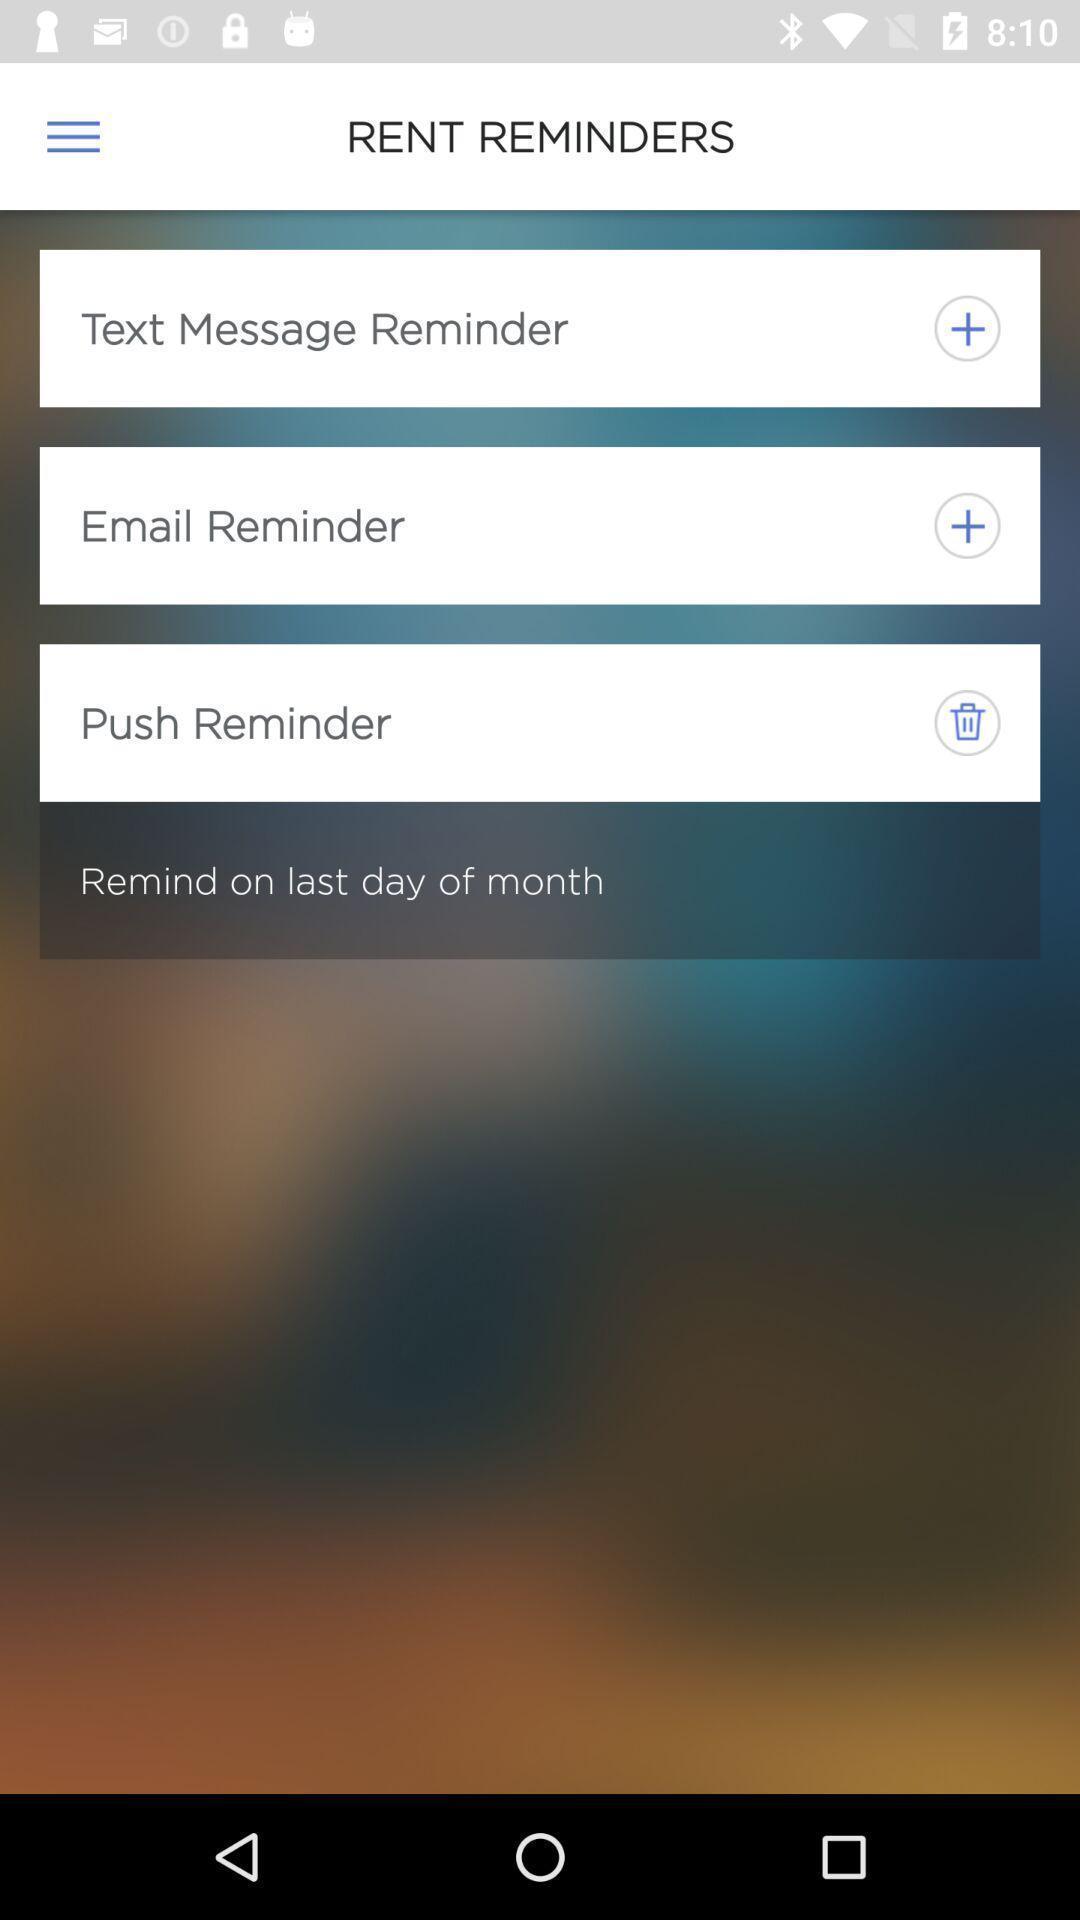Tell me what you see in this picture. Page displayed with reminder settings options. 